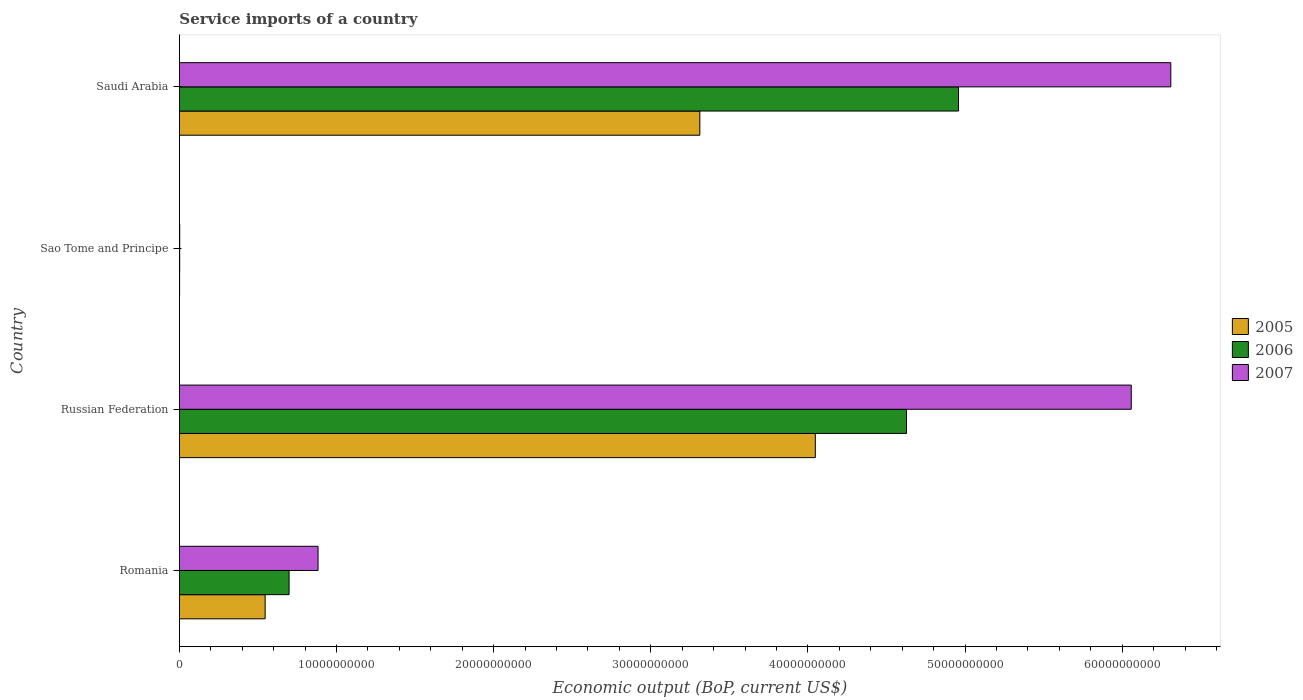How many different coloured bars are there?
Offer a very short reply. 3. Are the number of bars per tick equal to the number of legend labels?
Offer a very short reply. Yes. How many bars are there on the 4th tick from the top?
Make the answer very short. 3. How many bars are there on the 4th tick from the bottom?
Make the answer very short. 3. What is the label of the 1st group of bars from the top?
Provide a succinct answer. Saudi Arabia. What is the service imports in 2005 in Romania?
Ensure brevity in your answer.  5.46e+09. Across all countries, what is the maximum service imports in 2006?
Your answer should be very brief. 4.96e+1. Across all countries, what is the minimum service imports in 2006?
Your response must be concise. 1.78e+07. In which country was the service imports in 2006 maximum?
Make the answer very short. Saudi Arabia. In which country was the service imports in 2007 minimum?
Make the answer very short. Sao Tome and Principe. What is the total service imports in 2006 in the graph?
Provide a succinct answer. 1.03e+11. What is the difference between the service imports in 2007 in Romania and that in Russian Federation?
Keep it short and to the point. -5.18e+1. What is the difference between the service imports in 2005 in Saudi Arabia and the service imports in 2007 in Sao Tome and Principe?
Give a very brief answer. 3.31e+1. What is the average service imports in 2005 per country?
Ensure brevity in your answer.  1.98e+1. What is the difference between the service imports in 2006 and service imports in 2005 in Romania?
Make the answer very short. 1.52e+09. In how many countries, is the service imports in 2005 greater than 52000000000 US$?
Offer a very short reply. 0. What is the ratio of the service imports in 2006 in Romania to that in Saudi Arabia?
Provide a short and direct response. 0.14. Is the service imports in 2006 in Romania less than that in Sao Tome and Principe?
Offer a very short reply. No. Is the difference between the service imports in 2006 in Romania and Saudi Arabia greater than the difference between the service imports in 2005 in Romania and Saudi Arabia?
Give a very brief answer. No. What is the difference between the highest and the second highest service imports in 2006?
Give a very brief answer. 3.31e+09. What is the difference between the highest and the lowest service imports in 2007?
Keep it short and to the point. 6.31e+1. Is the sum of the service imports in 2005 in Sao Tome and Principe and Saudi Arabia greater than the maximum service imports in 2007 across all countries?
Your answer should be very brief. No. How many bars are there?
Give a very brief answer. 12. Does the graph contain any zero values?
Your answer should be compact. No. Does the graph contain grids?
Offer a very short reply. No. Where does the legend appear in the graph?
Keep it short and to the point. Center right. How many legend labels are there?
Offer a very short reply. 3. What is the title of the graph?
Your answer should be very brief. Service imports of a country. What is the label or title of the X-axis?
Offer a terse response. Economic output (BoP, current US$). What is the label or title of the Y-axis?
Give a very brief answer. Country. What is the Economic output (BoP, current US$) in 2005 in Romania?
Ensure brevity in your answer.  5.46e+09. What is the Economic output (BoP, current US$) in 2006 in Romania?
Provide a succinct answer. 6.98e+09. What is the Economic output (BoP, current US$) of 2007 in Romania?
Make the answer very short. 8.82e+09. What is the Economic output (BoP, current US$) in 2005 in Russian Federation?
Ensure brevity in your answer.  4.05e+1. What is the Economic output (BoP, current US$) of 2006 in Russian Federation?
Your answer should be very brief. 4.63e+1. What is the Economic output (BoP, current US$) in 2007 in Russian Federation?
Your answer should be compact. 6.06e+1. What is the Economic output (BoP, current US$) in 2005 in Sao Tome and Principe?
Ensure brevity in your answer.  1.11e+07. What is the Economic output (BoP, current US$) of 2006 in Sao Tome and Principe?
Your response must be concise. 1.78e+07. What is the Economic output (BoP, current US$) in 2007 in Sao Tome and Principe?
Ensure brevity in your answer.  1.87e+07. What is the Economic output (BoP, current US$) of 2005 in Saudi Arabia?
Provide a short and direct response. 3.31e+1. What is the Economic output (BoP, current US$) of 2006 in Saudi Arabia?
Provide a succinct answer. 4.96e+1. What is the Economic output (BoP, current US$) in 2007 in Saudi Arabia?
Your response must be concise. 6.31e+1. Across all countries, what is the maximum Economic output (BoP, current US$) in 2005?
Offer a very short reply. 4.05e+1. Across all countries, what is the maximum Economic output (BoP, current US$) of 2006?
Your answer should be very brief. 4.96e+1. Across all countries, what is the maximum Economic output (BoP, current US$) in 2007?
Ensure brevity in your answer.  6.31e+1. Across all countries, what is the minimum Economic output (BoP, current US$) of 2005?
Your response must be concise. 1.11e+07. Across all countries, what is the minimum Economic output (BoP, current US$) in 2006?
Give a very brief answer. 1.78e+07. Across all countries, what is the minimum Economic output (BoP, current US$) of 2007?
Offer a very short reply. 1.87e+07. What is the total Economic output (BoP, current US$) of 2005 in the graph?
Give a very brief answer. 7.91e+1. What is the total Economic output (BoP, current US$) in 2006 in the graph?
Provide a succinct answer. 1.03e+11. What is the total Economic output (BoP, current US$) of 2007 in the graph?
Your answer should be very brief. 1.33e+11. What is the difference between the Economic output (BoP, current US$) in 2005 in Romania and that in Russian Federation?
Give a very brief answer. -3.50e+1. What is the difference between the Economic output (BoP, current US$) of 2006 in Romania and that in Russian Federation?
Offer a terse response. -3.93e+1. What is the difference between the Economic output (BoP, current US$) of 2007 in Romania and that in Russian Federation?
Ensure brevity in your answer.  -5.18e+1. What is the difference between the Economic output (BoP, current US$) in 2005 in Romania and that in Sao Tome and Principe?
Offer a very short reply. 5.44e+09. What is the difference between the Economic output (BoP, current US$) in 2006 in Romania and that in Sao Tome and Principe?
Ensure brevity in your answer.  6.96e+09. What is the difference between the Economic output (BoP, current US$) of 2007 in Romania and that in Sao Tome and Principe?
Provide a succinct answer. 8.80e+09. What is the difference between the Economic output (BoP, current US$) of 2005 in Romania and that in Saudi Arabia?
Your response must be concise. -2.77e+1. What is the difference between the Economic output (BoP, current US$) in 2006 in Romania and that in Saudi Arabia?
Your answer should be compact. -4.26e+1. What is the difference between the Economic output (BoP, current US$) in 2007 in Romania and that in Saudi Arabia?
Your answer should be very brief. -5.43e+1. What is the difference between the Economic output (BoP, current US$) in 2005 in Russian Federation and that in Sao Tome and Principe?
Offer a very short reply. 4.05e+1. What is the difference between the Economic output (BoP, current US$) of 2006 in Russian Federation and that in Sao Tome and Principe?
Keep it short and to the point. 4.63e+1. What is the difference between the Economic output (BoP, current US$) in 2007 in Russian Federation and that in Sao Tome and Principe?
Provide a succinct answer. 6.06e+1. What is the difference between the Economic output (BoP, current US$) of 2005 in Russian Federation and that in Saudi Arabia?
Give a very brief answer. 7.35e+09. What is the difference between the Economic output (BoP, current US$) of 2006 in Russian Federation and that in Saudi Arabia?
Offer a very short reply. -3.31e+09. What is the difference between the Economic output (BoP, current US$) in 2007 in Russian Federation and that in Saudi Arabia?
Provide a succinct answer. -2.52e+09. What is the difference between the Economic output (BoP, current US$) of 2005 in Sao Tome and Principe and that in Saudi Arabia?
Your response must be concise. -3.31e+1. What is the difference between the Economic output (BoP, current US$) in 2006 in Sao Tome and Principe and that in Saudi Arabia?
Provide a succinct answer. -4.96e+1. What is the difference between the Economic output (BoP, current US$) of 2007 in Sao Tome and Principe and that in Saudi Arabia?
Ensure brevity in your answer.  -6.31e+1. What is the difference between the Economic output (BoP, current US$) in 2005 in Romania and the Economic output (BoP, current US$) in 2006 in Russian Federation?
Your answer should be compact. -4.08e+1. What is the difference between the Economic output (BoP, current US$) of 2005 in Romania and the Economic output (BoP, current US$) of 2007 in Russian Federation?
Offer a terse response. -5.51e+1. What is the difference between the Economic output (BoP, current US$) in 2006 in Romania and the Economic output (BoP, current US$) in 2007 in Russian Federation?
Your answer should be compact. -5.36e+1. What is the difference between the Economic output (BoP, current US$) in 2005 in Romania and the Economic output (BoP, current US$) in 2006 in Sao Tome and Principe?
Keep it short and to the point. 5.44e+09. What is the difference between the Economic output (BoP, current US$) in 2005 in Romania and the Economic output (BoP, current US$) in 2007 in Sao Tome and Principe?
Provide a succinct answer. 5.44e+09. What is the difference between the Economic output (BoP, current US$) in 2006 in Romania and the Economic output (BoP, current US$) in 2007 in Sao Tome and Principe?
Offer a very short reply. 6.96e+09. What is the difference between the Economic output (BoP, current US$) in 2005 in Romania and the Economic output (BoP, current US$) in 2006 in Saudi Arabia?
Your answer should be very brief. -4.41e+1. What is the difference between the Economic output (BoP, current US$) in 2005 in Romania and the Economic output (BoP, current US$) in 2007 in Saudi Arabia?
Your response must be concise. -5.76e+1. What is the difference between the Economic output (BoP, current US$) in 2006 in Romania and the Economic output (BoP, current US$) in 2007 in Saudi Arabia?
Make the answer very short. -5.61e+1. What is the difference between the Economic output (BoP, current US$) of 2005 in Russian Federation and the Economic output (BoP, current US$) of 2006 in Sao Tome and Principe?
Give a very brief answer. 4.05e+1. What is the difference between the Economic output (BoP, current US$) of 2005 in Russian Federation and the Economic output (BoP, current US$) of 2007 in Sao Tome and Principe?
Offer a very short reply. 4.05e+1. What is the difference between the Economic output (BoP, current US$) in 2006 in Russian Federation and the Economic output (BoP, current US$) in 2007 in Sao Tome and Principe?
Give a very brief answer. 4.63e+1. What is the difference between the Economic output (BoP, current US$) of 2005 in Russian Federation and the Economic output (BoP, current US$) of 2006 in Saudi Arabia?
Keep it short and to the point. -9.11e+09. What is the difference between the Economic output (BoP, current US$) of 2005 in Russian Federation and the Economic output (BoP, current US$) of 2007 in Saudi Arabia?
Your response must be concise. -2.26e+1. What is the difference between the Economic output (BoP, current US$) in 2006 in Russian Federation and the Economic output (BoP, current US$) in 2007 in Saudi Arabia?
Ensure brevity in your answer.  -1.68e+1. What is the difference between the Economic output (BoP, current US$) of 2005 in Sao Tome and Principe and the Economic output (BoP, current US$) of 2006 in Saudi Arabia?
Your response must be concise. -4.96e+1. What is the difference between the Economic output (BoP, current US$) of 2005 in Sao Tome and Principe and the Economic output (BoP, current US$) of 2007 in Saudi Arabia?
Your answer should be compact. -6.31e+1. What is the difference between the Economic output (BoP, current US$) of 2006 in Sao Tome and Principe and the Economic output (BoP, current US$) of 2007 in Saudi Arabia?
Your response must be concise. -6.31e+1. What is the average Economic output (BoP, current US$) of 2005 per country?
Make the answer very short. 1.98e+1. What is the average Economic output (BoP, current US$) in 2006 per country?
Make the answer very short. 2.57e+1. What is the average Economic output (BoP, current US$) in 2007 per country?
Your response must be concise. 3.31e+1. What is the difference between the Economic output (BoP, current US$) of 2005 and Economic output (BoP, current US$) of 2006 in Romania?
Offer a terse response. -1.52e+09. What is the difference between the Economic output (BoP, current US$) of 2005 and Economic output (BoP, current US$) of 2007 in Romania?
Provide a succinct answer. -3.37e+09. What is the difference between the Economic output (BoP, current US$) in 2006 and Economic output (BoP, current US$) in 2007 in Romania?
Give a very brief answer. -1.84e+09. What is the difference between the Economic output (BoP, current US$) in 2005 and Economic output (BoP, current US$) in 2006 in Russian Federation?
Keep it short and to the point. -5.80e+09. What is the difference between the Economic output (BoP, current US$) in 2005 and Economic output (BoP, current US$) in 2007 in Russian Federation?
Your response must be concise. -2.01e+1. What is the difference between the Economic output (BoP, current US$) of 2006 and Economic output (BoP, current US$) of 2007 in Russian Federation?
Provide a succinct answer. -1.43e+1. What is the difference between the Economic output (BoP, current US$) of 2005 and Economic output (BoP, current US$) of 2006 in Sao Tome and Principe?
Provide a succinct answer. -6.70e+06. What is the difference between the Economic output (BoP, current US$) of 2005 and Economic output (BoP, current US$) of 2007 in Sao Tome and Principe?
Provide a succinct answer. -7.61e+06. What is the difference between the Economic output (BoP, current US$) of 2006 and Economic output (BoP, current US$) of 2007 in Sao Tome and Principe?
Provide a short and direct response. -9.06e+05. What is the difference between the Economic output (BoP, current US$) of 2005 and Economic output (BoP, current US$) of 2006 in Saudi Arabia?
Your answer should be compact. -1.65e+1. What is the difference between the Economic output (BoP, current US$) of 2005 and Economic output (BoP, current US$) of 2007 in Saudi Arabia?
Keep it short and to the point. -3.00e+1. What is the difference between the Economic output (BoP, current US$) in 2006 and Economic output (BoP, current US$) in 2007 in Saudi Arabia?
Provide a short and direct response. -1.35e+1. What is the ratio of the Economic output (BoP, current US$) of 2005 in Romania to that in Russian Federation?
Give a very brief answer. 0.13. What is the ratio of the Economic output (BoP, current US$) in 2006 in Romania to that in Russian Federation?
Give a very brief answer. 0.15. What is the ratio of the Economic output (BoP, current US$) of 2007 in Romania to that in Russian Federation?
Give a very brief answer. 0.15. What is the ratio of the Economic output (BoP, current US$) in 2005 in Romania to that in Sao Tome and Principe?
Your answer should be very brief. 493.13. What is the ratio of the Economic output (BoP, current US$) of 2006 in Romania to that in Sao Tome and Principe?
Keep it short and to the point. 392.89. What is the ratio of the Economic output (BoP, current US$) of 2007 in Romania to that in Sao Tome and Principe?
Provide a short and direct response. 472.6. What is the ratio of the Economic output (BoP, current US$) of 2005 in Romania to that in Saudi Arabia?
Give a very brief answer. 0.16. What is the ratio of the Economic output (BoP, current US$) in 2006 in Romania to that in Saudi Arabia?
Give a very brief answer. 0.14. What is the ratio of the Economic output (BoP, current US$) of 2007 in Romania to that in Saudi Arabia?
Offer a very short reply. 0.14. What is the ratio of the Economic output (BoP, current US$) in 2005 in Russian Federation to that in Sao Tome and Principe?
Make the answer very short. 3657.96. What is the ratio of the Economic output (BoP, current US$) in 2006 in Russian Federation to that in Sao Tome and Principe?
Your response must be concise. 2604.97. What is the ratio of the Economic output (BoP, current US$) of 2007 in Russian Federation to that in Sao Tome and Principe?
Make the answer very short. 3244.84. What is the ratio of the Economic output (BoP, current US$) of 2005 in Russian Federation to that in Saudi Arabia?
Make the answer very short. 1.22. What is the ratio of the Economic output (BoP, current US$) of 2007 in Russian Federation to that in Saudi Arabia?
Ensure brevity in your answer.  0.96. What is the ratio of the Economic output (BoP, current US$) in 2006 in Sao Tome and Principe to that in Saudi Arabia?
Your answer should be very brief. 0. What is the ratio of the Economic output (BoP, current US$) of 2007 in Sao Tome and Principe to that in Saudi Arabia?
Provide a short and direct response. 0. What is the difference between the highest and the second highest Economic output (BoP, current US$) in 2005?
Provide a succinct answer. 7.35e+09. What is the difference between the highest and the second highest Economic output (BoP, current US$) of 2006?
Keep it short and to the point. 3.31e+09. What is the difference between the highest and the second highest Economic output (BoP, current US$) in 2007?
Your answer should be compact. 2.52e+09. What is the difference between the highest and the lowest Economic output (BoP, current US$) of 2005?
Your answer should be compact. 4.05e+1. What is the difference between the highest and the lowest Economic output (BoP, current US$) in 2006?
Provide a succinct answer. 4.96e+1. What is the difference between the highest and the lowest Economic output (BoP, current US$) in 2007?
Keep it short and to the point. 6.31e+1. 